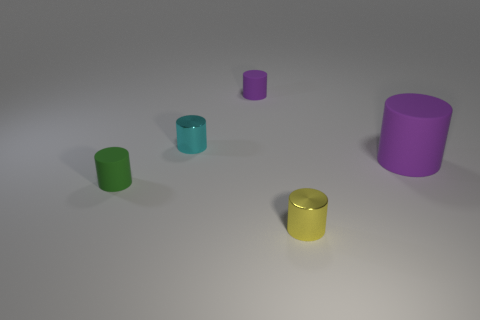Can you describe the size and color diversity among the objects in the image? Certainly! The image features five cylindrical objects of varying sizes and colors. There's a large purple cylinder, a medium-sized teal one, a small green one, the smallest one in cyan, and a medium-sized yellow one with a metallic sheen. Which object stands out the most in this image and why? The yellow metallic cylinder stands out the most due to its reflective surface and bright color, which contrasts strongly with the other matte-finished cylinders and the neutral background. 